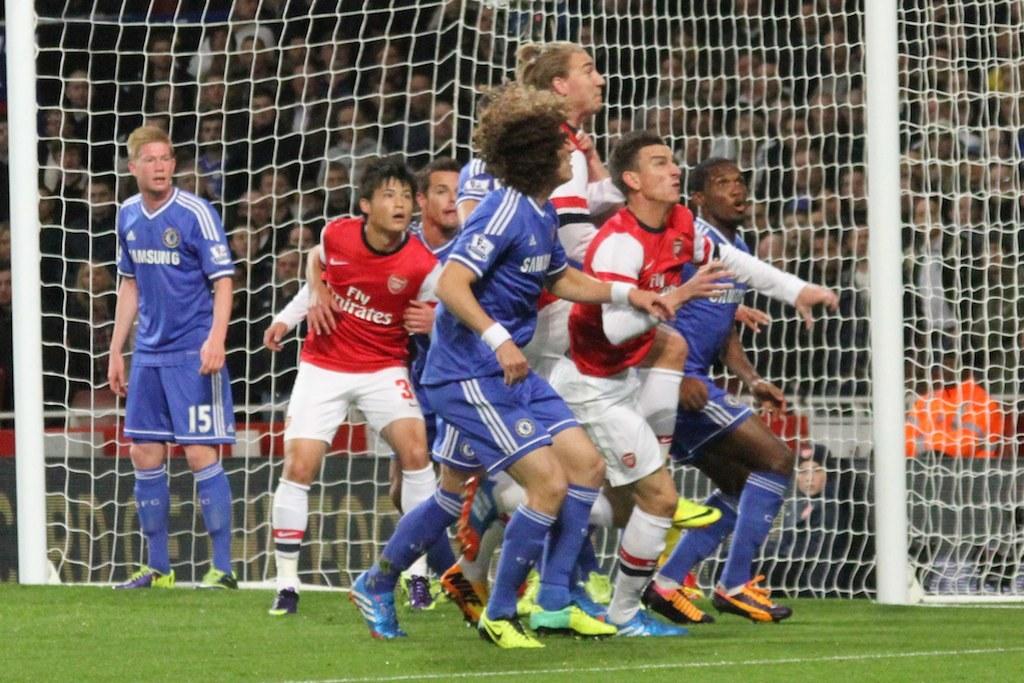What number is on the players shorts who is not part of the bunch?
Your answer should be very brief. 15. 